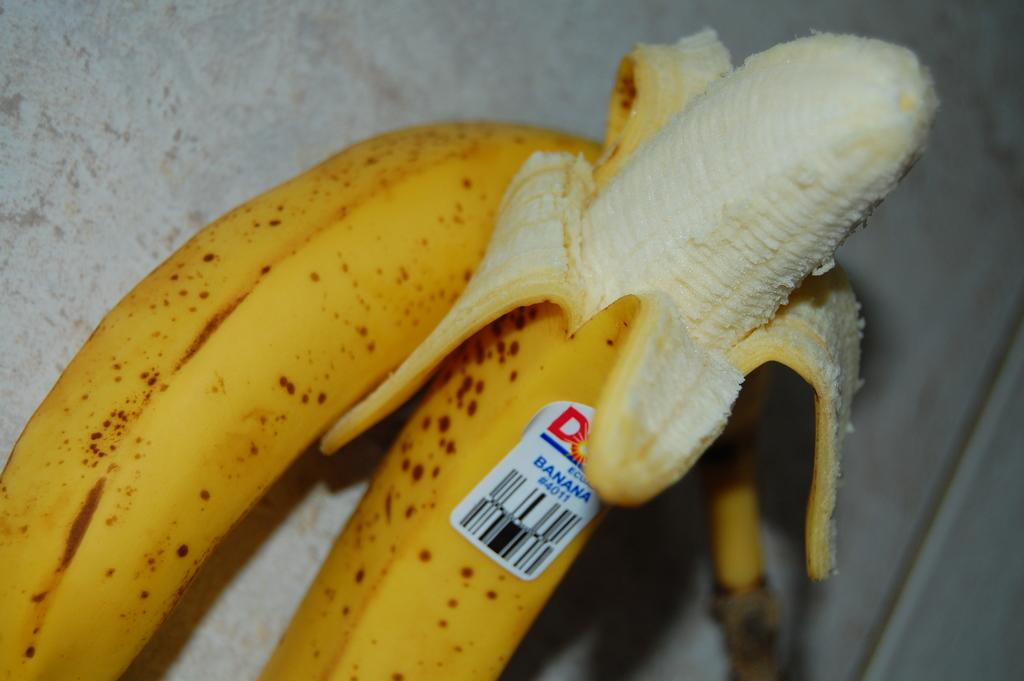How many bananas are visible in the image? There are two bananas in the image. Are there any distinguishing features on the bananas? Yes, one of the bananas has a sticker on it. What is the title of the book that is being supported by the bananas in the image? There is no book or title present in the image; it only features two bananas, one with a sticker. 